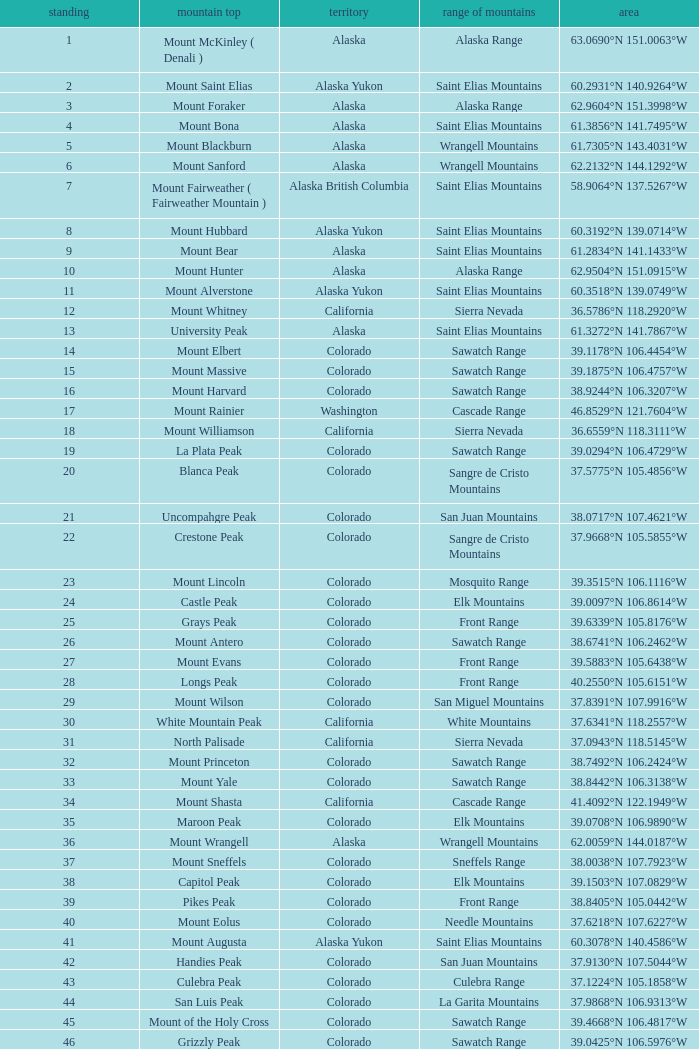What is the mountain range when the mountain peak is mauna kea? Island of Hawai ʻ i. 